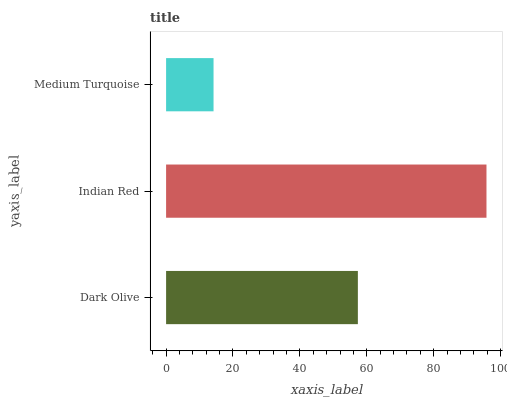Is Medium Turquoise the minimum?
Answer yes or no. Yes. Is Indian Red the maximum?
Answer yes or no. Yes. Is Indian Red the minimum?
Answer yes or no. No. Is Medium Turquoise the maximum?
Answer yes or no. No. Is Indian Red greater than Medium Turquoise?
Answer yes or no. Yes. Is Medium Turquoise less than Indian Red?
Answer yes or no. Yes. Is Medium Turquoise greater than Indian Red?
Answer yes or no. No. Is Indian Red less than Medium Turquoise?
Answer yes or no. No. Is Dark Olive the high median?
Answer yes or no. Yes. Is Dark Olive the low median?
Answer yes or no. Yes. Is Indian Red the high median?
Answer yes or no. No. Is Medium Turquoise the low median?
Answer yes or no. No. 